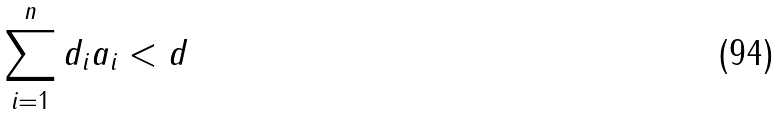<formula> <loc_0><loc_0><loc_500><loc_500>\sum _ { i = 1 } ^ { n } d _ { i } a _ { i } < d</formula> 